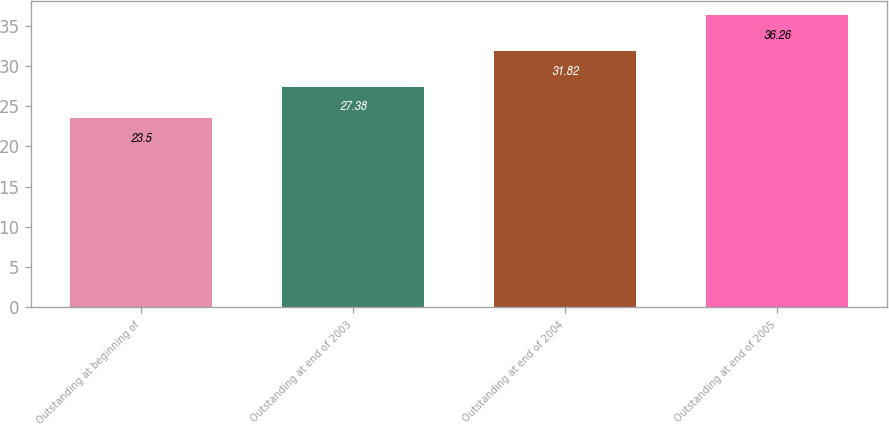Convert chart. <chart><loc_0><loc_0><loc_500><loc_500><bar_chart><fcel>Outstanding at beginning of<fcel>Outstanding at end of 2003<fcel>Outstanding at end of 2004<fcel>Outstanding at end of 2005<nl><fcel>23.5<fcel>27.38<fcel>31.82<fcel>36.26<nl></chart> 